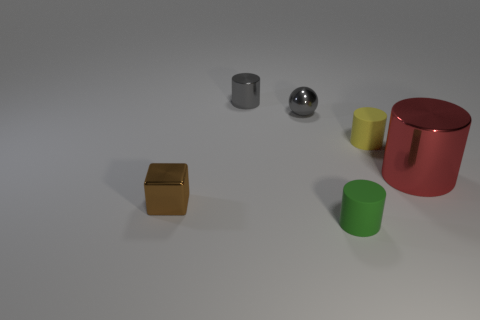Is there any other thing that has the same size as the red metallic cylinder?
Offer a very short reply. No. How many objects are small rubber cylinders in front of the tiny brown cube or matte objects that are behind the brown metallic block?
Provide a succinct answer. 2. How many gray things are either tiny metallic cubes or small metallic spheres?
Give a very brief answer. 1. What material is the small thing that is both in front of the yellow cylinder and to the left of the ball?
Your answer should be compact. Metal. Does the small gray sphere have the same material as the small brown object?
Your answer should be compact. Yes. How many other matte cylinders are the same size as the red cylinder?
Your response must be concise. 0. Are there an equal number of tiny green rubber things to the right of the yellow matte cylinder and small rubber balls?
Offer a terse response. Yes. What number of cylinders are to the right of the tiny shiny cylinder and behind the green cylinder?
Your answer should be very brief. 2. There is a red shiny object that is right of the small brown block; is it the same shape as the tiny brown object?
Offer a terse response. No. There is a green thing that is the same size as the yellow thing; what is it made of?
Ensure brevity in your answer.  Rubber. 